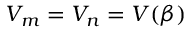<formula> <loc_0><loc_0><loc_500><loc_500>V _ { m } = V _ { n } = V ( \beta )</formula> 